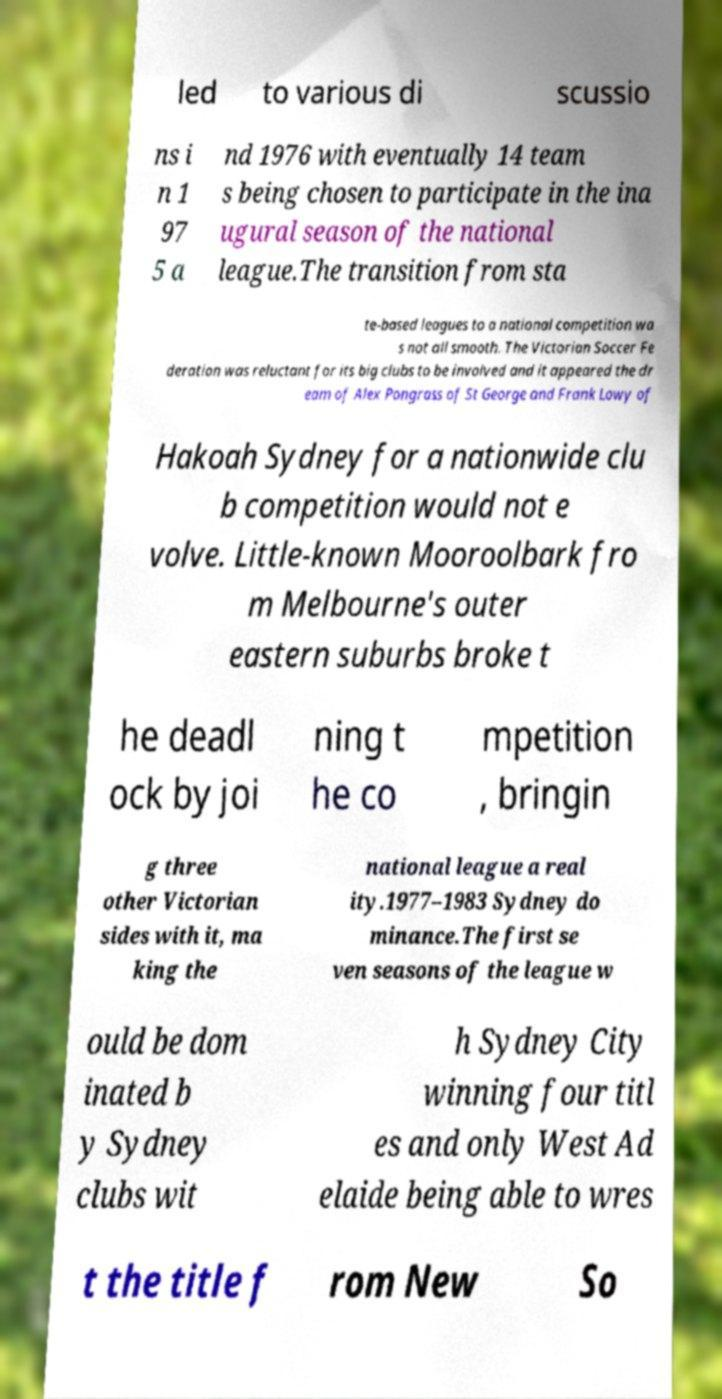Could you assist in decoding the text presented in this image and type it out clearly? led to various di scussio ns i n 1 97 5 a nd 1976 with eventually 14 team s being chosen to participate in the ina ugural season of the national league.The transition from sta te-based leagues to a national competition wa s not all smooth. The Victorian Soccer Fe deration was reluctant for its big clubs to be involved and it appeared the dr eam of Alex Pongrass of St George and Frank Lowy of Hakoah Sydney for a nationwide clu b competition would not e volve. Little-known Mooroolbark fro m Melbourne's outer eastern suburbs broke t he deadl ock by joi ning t he co mpetition , bringin g three other Victorian sides with it, ma king the national league a real ity.1977–1983 Sydney do minance.The first se ven seasons of the league w ould be dom inated b y Sydney clubs wit h Sydney City winning four titl es and only West Ad elaide being able to wres t the title f rom New So 